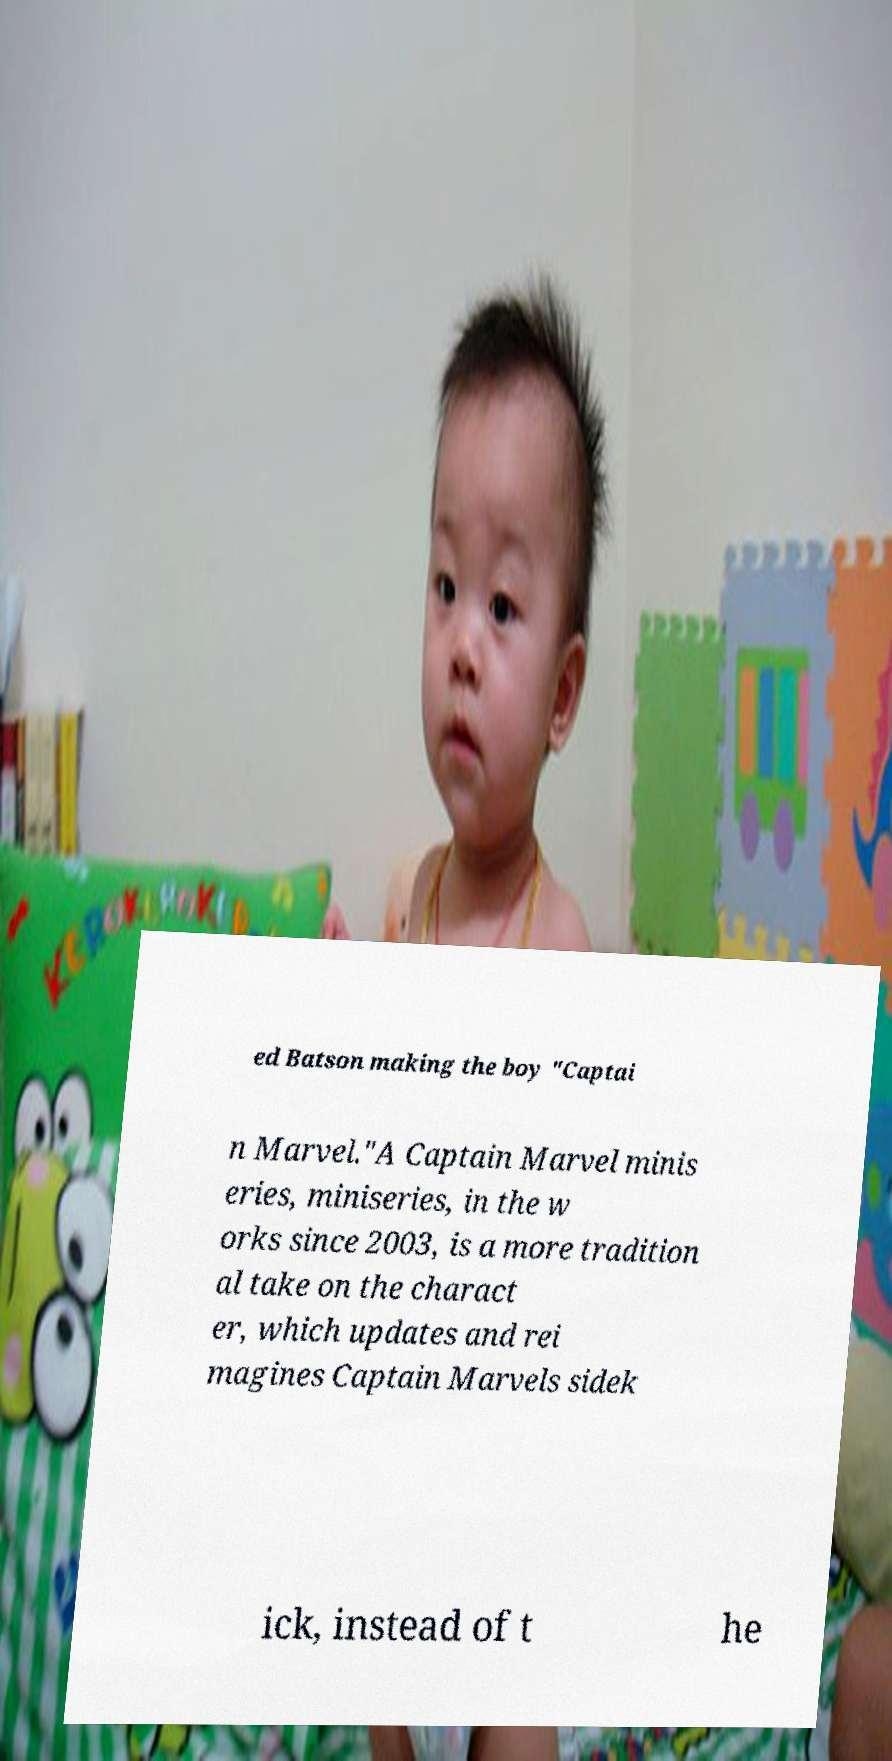Please identify and transcribe the text found in this image. ed Batson making the boy "Captai n Marvel."A Captain Marvel minis eries, miniseries, in the w orks since 2003, is a more tradition al take on the charact er, which updates and rei magines Captain Marvels sidek ick, instead of t he 